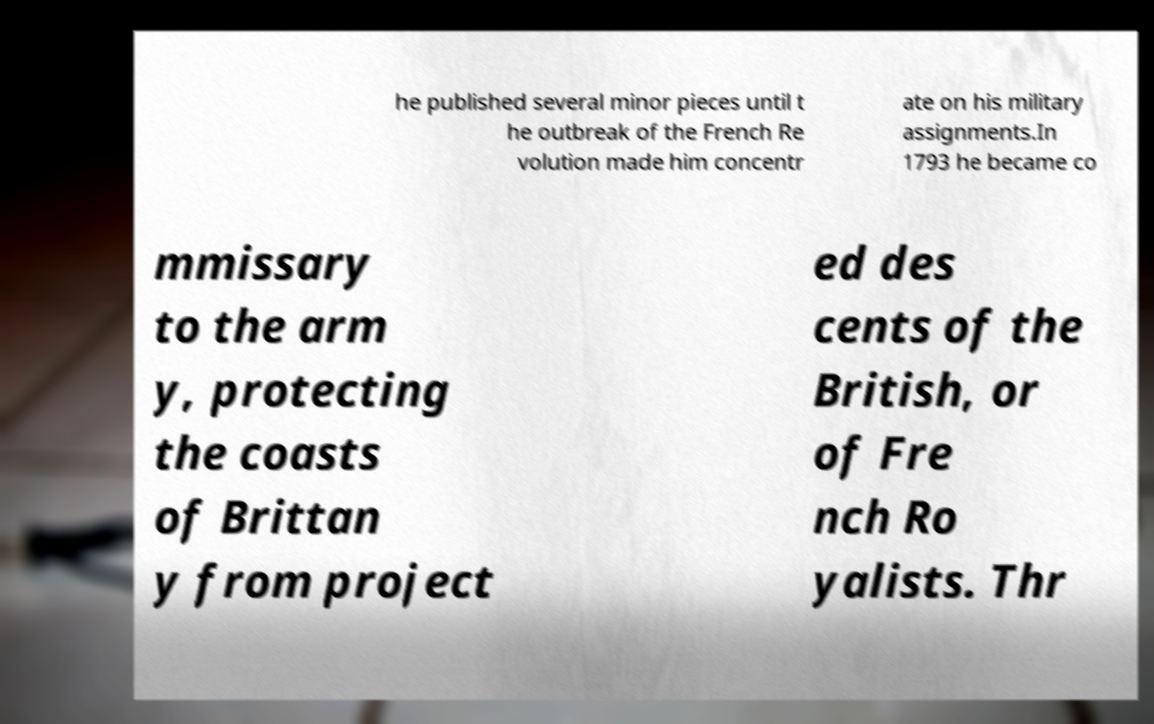Please identify and transcribe the text found in this image. he published several minor pieces until t he outbreak of the French Re volution made him concentr ate on his military assignments.In 1793 he became co mmissary to the arm y, protecting the coasts of Brittan y from project ed des cents of the British, or of Fre nch Ro yalists. Thr 